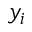Convert formula to latex. <formula><loc_0><loc_0><loc_500><loc_500>y _ { i }</formula> 